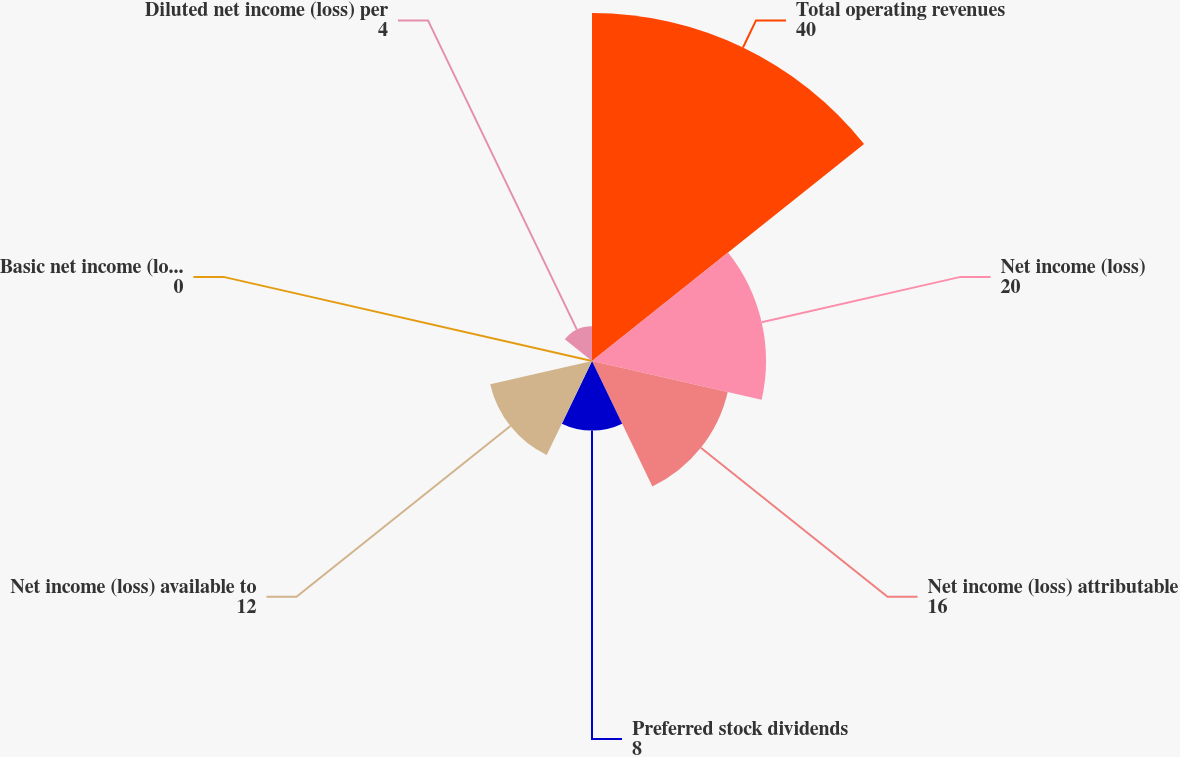Convert chart. <chart><loc_0><loc_0><loc_500><loc_500><pie_chart><fcel>Total operating revenues<fcel>Net income (loss)<fcel>Net income (loss) attributable<fcel>Preferred stock dividends<fcel>Net income (loss) available to<fcel>Basic net income (loss) per<fcel>Diluted net income (loss) per<nl><fcel>40.0%<fcel>20.0%<fcel>16.0%<fcel>8.0%<fcel>12.0%<fcel>0.0%<fcel>4.0%<nl></chart> 